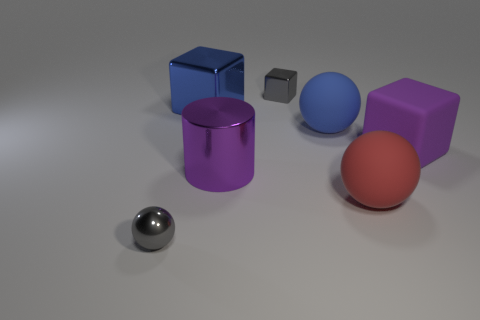Subtract all big blue matte balls. How many balls are left? 2 Add 1 tiny gray rubber spheres. How many objects exist? 8 Subtract all blue balls. How many balls are left? 2 Subtract all cylinders. How many objects are left? 6 Add 6 cubes. How many cubes exist? 9 Subtract 0 green balls. How many objects are left? 7 Subtract 1 cubes. How many cubes are left? 2 Subtract all cyan cylinders. Subtract all purple cubes. How many cylinders are left? 1 Subtract all green cubes. How many yellow cylinders are left? 0 Subtract all big blue rubber cubes. Subtract all big purple rubber objects. How many objects are left? 6 